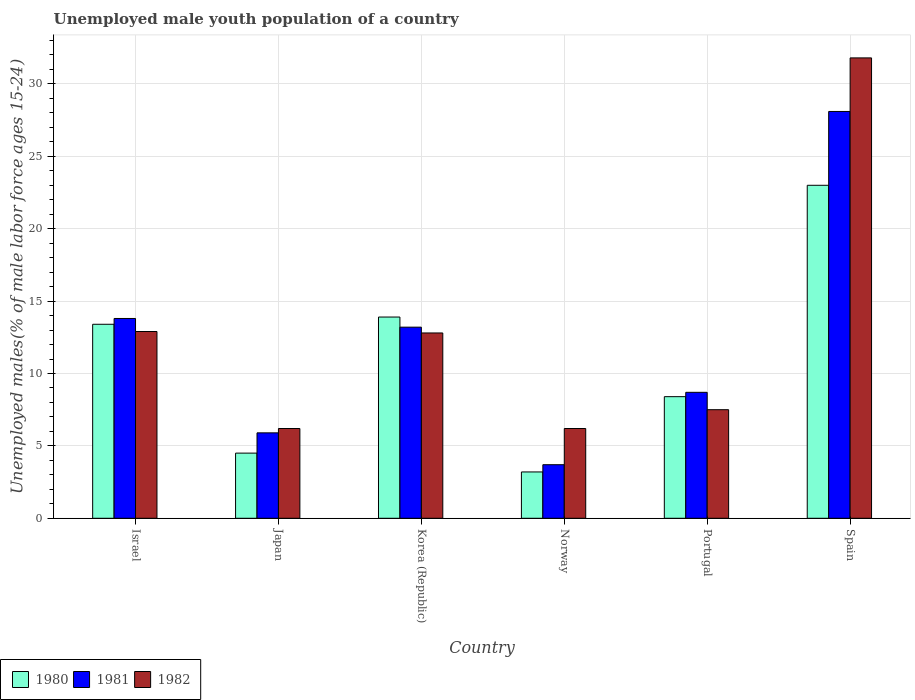How many groups of bars are there?
Provide a short and direct response. 6. How many bars are there on the 3rd tick from the right?
Keep it short and to the point. 3. What is the label of the 3rd group of bars from the left?
Your response must be concise. Korea (Republic). In how many cases, is the number of bars for a given country not equal to the number of legend labels?
Offer a very short reply. 0. What is the percentage of unemployed male youth population in 1980 in Norway?
Keep it short and to the point. 3.2. Across all countries, what is the maximum percentage of unemployed male youth population in 1980?
Your answer should be very brief. 23. Across all countries, what is the minimum percentage of unemployed male youth population in 1981?
Make the answer very short. 3.7. What is the total percentage of unemployed male youth population in 1981 in the graph?
Offer a terse response. 73.4. What is the difference between the percentage of unemployed male youth population in 1982 in Israel and that in Portugal?
Provide a short and direct response. 5.4. What is the difference between the percentage of unemployed male youth population in 1981 in Portugal and the percentage of unemployed male youth population in 1980 in Norway?
Your answer should be compact. 5.5. What is the average percentage of unemployed male youth population in 1982 per country?
Your answer should be compact. 12.9. What is the difference between the percentage of unemployed male youth population of/in 1981 and percentage of unemployed male youth population of/in 1982 in Portugal?
Keep it short and to the point. 1.2. In how many countries, is the percentage of unemployed male youth population in 1981 greater than 20 %?
Offer a terse response. 1. What is the ratio of the percentage of unemployed male youth population in 1981 in Japan to that in Norway?
Your response must be concise. 1.59. Is the difference between the percentage of unemployed male youth population in 1981 in Israel and Norway greater than the difference between the percentage of unemployed male youth population in 1982 in Israel and Norway?
Provide a short and direct response. Yes. What is the difference between the highest and the second highest percentage of unemployed male youth population in 1981?
Keep it short and to the point. -14.9. What is the difference between the highest and the lowest percentage of unemployed male youth population in 1981?
Make the answer very short. 24.4. What does the 3rd bar from the left in Portugal represents?
Your answer should be compact. 1982. Is it the case that in every country, the sum of the percentage of unemployed male youth population in 1980 and percentage of unemployed male youth population in 1981 is greater than the percentage of unemployed male youth population in 1982?
Keep it short and to the point. Yes. Are all the bars in the graph horizontal?
Ensure brevity in your answer.  No. How many countries are there in the graph?
Provide a succinct answer. 6. What is the difference between two consecutive major ticks on the Y-axis?
Your answer should be compact. 5. Are the values on the major ticks of Y-axis written in scientific E-notation?
Keep it short and to the point. No. Where does the legend appear in the graph?
Offer a very short reply. Bottom left. How many legend labels are there?
Your answer should be very brief. 3. How are the legend labels stacked?
Offer a terse response. Horizontal. What is the title of the graph?
Give a very brief answer. Unemployed male youth population of a country. Does "1963" appear as one of the legend labels in the graph?
Give a very brief answer. No. What is the label or title of the X-axis?
Give a very brief answer. Country. What is the label or title of the Y-axis?
Your answer should be very brief. Unemployed males(% of male labor force ages 15-24). What is the Unemployed males(% of male labor force ages 15-24) in 1980 in Israel?
Offer a very short reply. 13.4. What is the Unemployed males(% of male labor force ages 15-24) in 1981 in Israel?
Offer a terse response. 13.8. What is the Unemployed males(% of male labor force ages 15-24) in 1982 in Israel?
Give a very brief answer. 12.9. What is the Unemployed males(% of male labor force ages 15-24) in 1980 in Japan?
Provide a succinct answer. 4.5. What is the Unemployed males(% of male labor force ages 15-24) in 1981 in Japan?
Offer a very short reply. 5.9. What is the Unemployed males(% of male labor force ages 15-24) of 1982 in Japan?
Provide a short and direct response. 6.2. What is the Unemployed males(% of male labor force ages 15-24) in 1980 in Korea (Republic)?
Your answer should be compact. 13.9. What is the Unemployed males(% of male labor force ages 15-24) of 1981 in Korea (Republic)?
Offer a very short reply. 13.2. What is the Unemployed males(% of male labor force ages 15-24) in 1982 in Korea (Republic)?
Your answer should be compact. 12.8. What is the Unemployed males(% of male labor force ages 15-24) of 1980 in Norway?
Offer a terse response. 3.2. What is the Unemployed males(% of male labor force ages 15-24) in 1981 in Norway?
Provide a short and direct response. 3.7. What is the Unemployed males(% of male labor force ages 15-24) in 1982 in Norway?
Offer a terse response. 6.2. What is the Unemployed males(% of male labor force ages 15-24) in 1980 in Portugal?
Your response must be concise. 8.4. What is the Unemployed males(% of male labor force ages 15-24) in 1981 in Portugal?
Your answer should be very brief. 8.7. What is the Unemployed males(% of male labor force ages 15-24) of 1982 in Portugal?
Your response must be concise. 7.5. What is the Unemployed males(% of male labor force ages 15-24) in 1980 in Spain?
Make the answer very short. 23. What is the Unemployed males(% of male labor force ages 15-24) in 1981 in Spain?
Ensure brevity in your answer.  28.1. What is the Unemployed males(% of male labor force ages 15-24) in 1982 in Spain?
Offer a terse response. 31.8. Across all countries, what is the maximum Unemployed males(% of male labor force ages 15-24) in 1981?
Your answer should be very brief. 28.1. Across all countries, what is the maximum Unemployed males(% of male labor force ages 15-24) in 1982?
Provide a succinct answer. 31.8. Across all countries, what is the minimum Unemployed males(% of male labor force ages 15-24) in 1980?
Provide a succinct answer. 3.2. Across all countries, what is the minimum Unemployed males(% of male labor force ages 15-24) of 1981?
Provide a short and direct response. 3.7. Across all countries, what is the minimum Unemployed males(% of male labor force ages 15-24) in 1982?
Offer a very short reply. 6.2. What is the total Unemployed males(% of male labor force ages 15-24) in 1980 in the graph?
Your answer should be compact. 66.4. What is the total Unemployed males(% of male labor force ages 15-24) of 1981 in the graph?
Your answer should be very brief. 73.4. What is the total Unemployed males(% of male labor force ages 15-24) in 1982 in the graph?
Provide a short and direct response. 77.4. What is the difference between the Unemployed males(% of male labor force ages 15-24) of 1980 in Israel and that in Japan?
Offer a very short reply. 8.9. What is the difference between the Unemployed males(% of male labor force ages 15-24) in 1981 in Israel and that in Norway?
Make the answer very short. 10.1. What is the difference between the Unemployed males(% of male labor force ages 15-24) of 1982 in Israel and that in Norway?
Offer a very short reply. 6.7. What is the difference between the Unemployed males(% of male labor force ages 15-24) of 1982 in Israel and that in Portugal?
Offer a terse response. 5.4. What is the difference between the Unemployed males(% of male labor force ages 15-24) of 1981 in Israel and that in Spain?
Offer a very short reply. -14.3. What is the difference between the Unemployed males(% of male labor force ages 15-24) in 1982 in Israel and that in Spain?
Provide a succinct answer. -18.9. What is the difference between the Unemployed males(% of male labor force ages 15-24) in 1980 in Japan and that in Korea (Republic)?
Give a very brief answer. -9.4. What is the difference between the Unemployed males(% of male labor force ages 15-24) of 1982 in Japan and that in Korea (Republic)?
Your response must be concise. -6.6. What is the difference between the Unemployed males(% of male labor force ages 15-24) of 1981 in Japan and that in Norway?
Your answer should be very brief. 2.2. What is the difference between the Unemployed males(% of male labor force ages 15-24) of 1981 in Japan and that in Portugal?
Offer a terse response. -2.8. What is the difference between the Unemployed males(% of male labor force ages 15-24) of 1980 in Japan and that in Spain?
Give a very brief answer. -18.5. What is the difference between the Unemployed males(% of male labor force ages 15-24) of 1981 in Japan and that in Spain?
Ensure brevity in your answer.  -22.2. What is the difference between the Unemployed males(% of male labor force ages 15-24) of 1982 in Japan and that in Spain?
Give a very brief answer. -25.6. What is the difference between the Unemployed males(% of male labor force ages 15-24) of 1980 in Korea (Republic) and that in Norway?
Ensure brevity in your answer.  10.7. What is the difference between the Unemployed males(% of male labor force ages 15-24) in 1982 in Korea (Republic) and that in Portugal?
Provide a short and direct response. 5.3. What is the difference between the Unemployed males(% of male labor force ages 15-24) in 1981 in Korea (Republic) and that in Spain?
Make the answer very short. -14.9. What is the difference between the Unemployed males(% of male labor force ages 15-24) in 1982 in Korea (Republic) and that in Spain?
Your answer should be very brief. -19. What is the difference between the Unemployed males(% of male labor force ages 15-24) in 1981 in Norway and that in Portugal?
Make the answer very short. -5. What is the difference between the Unemployed males(% of male labor force ages 15-24) of 1982 in Norway and that in Portugal?
Provide a succinct answer. -1.3. What is the difference between the Unemployed males(% of male labor force ages 15-24) in 1980 in Norway and that in Spain?
Provide a short and direct response. -19.8. What is the difference between the Unemployed males(% of male labor force ages 15-24) in 1981 in Norway and that in Spain?
Give a very brief answer. -24.4. What is the difference between the Unemployed males(% of male labor force ages 15-24) in 1982 in Norway and that in Spain?
Your response must be concise. -25.6. What is the difference between the Unemployed males(% of male labor force ages 15-24) in 1980 in Portugal and that in Spain?
Provide a short and direct response. -14.6. What is the difference between the Unemployed males(% of male labor force ages 15-24) of 1981 in Portugal and that in Spain?
Keep it short and to the point. -19.4. What is the difference between the Unemployed males(% of male labor force ages 15-24) of 1982 in Portugal and that in Spain?
Keep it short and to the point. -24.3. What is the difference between the Unemployed males(% of male labor force ages 15-24) in 1980 in Israel and the Unemployed males(% of male labor force ages 15-24) in 1981 in Japan?
Give a very brief answer. 7.5. What is the difference between the Unemployed males(% of male labor force ages 15-24) in 1981 in Israel and the Unemployed males(% of male labor force ages 15-24) in 1982 in Japan?
Keep it short and to the point. 7.6. What is the difference between the Unemployed males(% of male labor force ages 15-24) of 1981 in Israel and the Unemployed males(% of male labor force ages 15-24) of 1982 in Korea (Republic)?
Offer a terse response. 1. What is the difference between the Unemployed males(% of male labor force ages 15-24) of 1981 in Israel and the Unemployed males(% of male labor force ages 15-24) of 1982 in Norway?
Your response must be concise. 7.6. What is the difference between the Unemployed males(% of male labor force ages 15-24) in 1981 in Israel and the Unemployed males(% of male labor force ages 15-24) in 1982 in Portugal?
Give a very brief answer. 6.3. What is the difference between the Unemployed males(% of male labor force ages 15-24) of 1980 in Israel and the Unemployed males(% of male labor force ages 15-24) of 1981 in Spain?
Offer a terse response. -14.7. What is the difference between the Unemployed males(% of male labor force ages 15-24) in 1980 in Israel and the Unemployed males(% of male labor force ages 15-24) in 1982 in Spain?
Your response must be concise. -18.4. What is the difference between the Unemployed males(% of male labor force ages 15-24) in 1981 in Israel and the Unemployed males(% of male labor force ages 15-24) in 1982 in Spain?
Offer a very short reply. -18. What is the difference between the Unemployed males(% of male labor force ages 15-24) in 1981 in Japan and the Unemployed males(% of male labor force ages 15-24) in 1982 in Korea (Republic)?
Offer a terse response. -6.9. What is the difference between the Unemployed males(% of male labor force ages 15-24) in 1981 in Japan and the Unemployed males(% of male labor force ages 15-24) in 1982 in Norway?
Offer a very short reply. -0.3. What is the difference between the Unemployed males(% of male labor force ages 15-24) of 1980 in Japan and the Unemployed males(% of male labor force ages 15-24) of 1981 in Spain?
Give a very brief answer. -23.6. What is the difference between the Unemployed males(% of male labor force ages 15-24) of 1980 in Japan and the Unemployed males(% of male labor force ages 15-24) of 1982 in Spain?
Provide a succinct answer. -27.3. What is the difference between the Unemployed males(% of male labor force ages 15-24) in 1981 in Japan and the Unemployed males(% of male labor force ages 15-24) in 1982 in Spain?
Make the answer very short. -25.9. What is the difference between the Unemployed males(% of male labor force ages 15-24) in 1980 in Korea (Republic) and the Unemployed males(% of male labor force ages 15-24) in 1981 in Norway?
Offer a very short reply. 10.2. What is the difference between the Unemployed males(% of male labor force ages 15-24) of 1981 in Korea (Republic) and the Unemployed males(% of male labor force ages 15-24) of 1982 in Norway?
Your response must be concise. 7. What is the difference between the Unemployed males(% of male labor force ages 15-24) in 1980 in Korea (Republic) and the Unemployed males(% of male labor force ages 15-24) in 1981 in Portugal?
Keep it short and to the point. 5.2. What is the difference between the Unemployed males(% of male labor force ages 15-24) in 1980 in Korea (Republic) and the Unemployed males(% of male labor force ages 15-24) in 1981 in Spain?
Make the answer very short. -14.2. What is the difference between the Unemployed males(% of male labor force ages 15-24) in 1980 in Korea (Republic) and the Unemployed males(% of male labor force ages 15-24) in 1982 in Spain?
Your answer should be compact. -17.9. What is the difference between the Unemployed males(% of male labor force ages 15-24) in 1981 in Korea (Republic) and the Unemployed males(% of male labor force ages 15-24) in 1982 in Spain?
Give a very brief answer. -18.6. What is the difference between the Unemployed males(% of male labor force ages 15-24) of 1980 in Norway and the Unemployed males(% of male labor force ages 15-24) of 1981 in Portugal?
Provide a succinct answer. -5.5. What is the difference between the Unemployed males(% of male labor force ages 15-24) in 1980 in Norway and the Unemployed males(% of male labor force ages 15-24) in 1982 in Portugal?
Make the answer very short. -4.3. What is the difference between the Unemployed males(% of male labor force ages 15-24) in 1980 in Norway and the Unemployed males(% of male labor force ages 15-24) in 1981 in Spain?
Your answer should be very brief. -24.9. What is the difference between the Unemployed males(% of male labor force ages 15-24) of 1980 in Norway and the Unemployed males(% of male labor force ages 15-24) of 1982 in Spain?
Make the answer very short. -28.6. What is the difference between the Unemployed males(% of male labor force ages 15-24) in 1981 in Norway and the Unemployed males(% of male labor force ages 15-24) in 1982 in Spain?
Provide a succinct answer. -28.1. What is the difference between the Unemployed males(% of male labor force ages 15-24) of 1980 in Portugal and the Unemployed males(% of male labor force ages 15-24) of 1981 in Spain?
Offer a very short reply. -19.7. What is the difference between the Unemployed males(% of male labor force ages 15-24) in 1980 in Portugal and the Unemployed males(% of male labor force ages 15-24) in 1982 in Spain?
Make the answer very short. -23.4. What is the difference between the Unemployed males(% of male labor force ages 15-24) in 1981 in Portugal and the Unemployed males(% of male labor force ages 15-24) in 1982 in Spain?
Your response must be concise. -23.1. What is the average Unemployed males(% of male labor force ages 15-24) of 1980 per country?
Provide a short and direct response. 11.07. What is the average Unemployed males(% of male labor force ages 15-24) in 1981 per country?
Offer a terse response. 12.23. What is the average Unemployed males(% of male labor force ages 15-24) of 1982 per country?
Offer a very short reply. 12.9. What is the difference between the Unemployed males(% of male labor force ages 15-24) in 1981 and Unemployed males(% of male labor force ages 15-24) in 1982 in Japan?
Ensure brevity in your answer.  -0.3. What is the difference between the Unemployed males(% of male labor force ages 15-24) of 1980 and Unemployed males(% of male labor force ages 15-24) of 1981 in Korea (Republic)?
Give a very brief answer. 0.7. What is the difference between the Unemployed males(% of male labor force ages 15-24) of 1980 and Unemployed males(% of male labor force ages 15-24) of 1982 in Korea (Republic)?
Ensure brevity in your answer.  1.1. What is the difference between the Unemployed males(% of male labor force ages 15-24) of 1980 and Unemployed males(% of male labor force ages 15-24) of 1981 in Norway?
Your answer should be very brief. -0.5. What is the difference between the Unemployed males(% of male labor force ages 15-24) in 1980 and Unemployed males(% of male labor force ages 15-24) in 1982 in Portugal?
Provide a short and direct response. 0.9. What is the difference between the Unemployed males(% of male labor force ages 15-24) of 1981 and Unemployed males(% of male labor force ages 15-24) of 1982 in Portugal?
Keep it short and to the point. 1.2. What is the difference between the Unemployed males(% of male labor force ages 15-24) in 1980 and Unemployed males(% of male labor force ages 15-24) in 1982 in Spain?
Give a very brief answer. -8.8. What is the ratio of the Unemployed males(% of male labor force ages 15-24) in 1980 in Israel to that in Japan?
Your answer should be very brief. 2.98. What is the ratio of the Unemployed males(% of male labor force ages 15-24) of 1981 in Israel to that in Japan?
Offer a terse response. 2.34. What is the ratio of the Unemployed males(% of male labor force ages 15-24) in 1982 in Israel to that in Japan?
Your response must be concise. 2.08. What is the ratio of the Unemployed males(% of male labor force ages 15-24) in 1980 in Israel to that in Korea (Republic)?
Keep it short and to the point. 0.96. What is the ratio of the Unemployed males(% of male labor force ages 15-24) of 1981 in Israel to that in Korea (Republic)?
Your answer should be very brief. 1.05. What is the ratio of the Unemployed males(% of male labor force ages 15-24) in 1982 in Israel to that in Korea (Republic)?
Offer a very short reply. 1.01. What is the ratio of the Unemployed males(% of male labor force ages 15-24) of 1980 in Israel to that in Norway?
Your answer should be compact. 4.19. What is the ratio of the Unemployed males(% of male labor force ages 15-24) in 1981 in Israel to that in Norway?
Provide a short and direct response. 3.73. What is the ratio of the Unemployed males(% of male labor force ages 15-24) in 1982 in Israel to that in Norway?
Keep it short and to the point. 2.08. What is the ratio of the Unemployed males(% of male labor force ages 15-24) of 1980 in Israel to that in Portugal?
Offer a very short reply. 1.6. What is the ratio of the Unemployed males(% of male labor force ages 15-24) in 1981 in Israel to that in Portugal?
Offer a terse response. 1.59. What is the ratio of the Unemployed males(% of male labor force ages 15-24) in 1982 in Israel to that in Portugal?
Your answer should be compact. 1.72. What is the ratio of the Unemployed males(% of male labor force ages 15-24) of 1980 in Israel to that in Spain?
Your answer should be compact. 0.58. What is the ratio of the Unemployed males(% of male labor force ages 15-24) in 1981 in Israel to that in Spain?
Your response must be concise. 0.49. What is the ratio of the Unemployed males(% of male labor force ages 15-24) in 1982 in Israel to that in Spain?
Your response must be concise. 0.41. What is the ratio of the Unemployed males(% of male labor force ages 15-24) of 1980 in Japan to that in Korea (Republic)?
Ensure brevity in your answer.  0.32. What is the ratio of the Unemployed males(% of male labor force ages 15-24) of 1981 in Japan to that in Korea (Republic)?
Offer a terse response. 0.45. What is the ratio of the Unemployed males(% of male labor force ages 15-24) in 1982 in Japan to that in Korea (Republic)?
Give a very brief answer. 0.48. What is the ratio of the Unemployed males(% of male labor force ages 15-24) in 1980 in Japan to that in Norway?
Provide a short and direct response. 1.41. What is the ratio of the Unemployed males(% of male labor force ages 15-24) in 1981 in Japan to that in Norway?
Your answer should be very brief. 1.59. What is the ratio of the Unemployed males(% of male labor force ages 15-24) of 1980 in Japan to that in Portugal?
Provide a short and direct response. 0.54. What is the ratio of the Unemployed males(% of male labor force ages 15-24) of 1981 in Japan to that in Portugal?
Give a very brief answer. 0.68. What is the ratio of the Unemployed males(% of male labor force ages 15-24) of 1982 in Japan to that in Portugal?
Make the answer very short. 0.83. What is the ratio of the Unemployed males(% of male labor force ages 15-24) in 1980 in Japan to that in Spain?
Give a very brief answer. 0.2. What is the ratio of the Unemployed males(% of male labor force ages 15-24) of 1981 in Japan to that in Spain?
Ensure brevity in your answer.  0.21. What is the ratio of the Unemployed males(% of male labor force ages 15-24) in 1982 in Japan to that in Spain?
Offer a terse response. 0.2. What is the ratio of the Unemployed males(% of male labor force ages 15-24) of 1980 in Korea (Republic) to that in Norway?
Give a very brief answer. 4.34. What is the ratio of the Unemployed males(% of male labor force ages 15-24) of 1981 in Korea (Republic) to that in Norway?
Provide a succinct answer. 3.57. What is the ratio of the Unemployed males(% of male labor force ages 15-24) in 1982 in Korea (Republic) to that in Norway?
Offer a terse response. 2.06. What is the ratio of the Unemployed males(% of male labor force ages 15-24) in 1980 in Korea (Republic) to that in Portugal?
Provide a succinct answer. 1.65. What is the ratio of the Unemployed males(% of male labor force ages 15-24) of 1981 in Korea (Republic) to that in Portugal?
Ensure brevity in your answer.  1.52. What is the ratio of the Unemployed males(% of male labor force ages 15-24) of 1982 in Korea (Republic) to that in Portugal?
Make the answer very short. 1.71. What is the ratio of the Unemployed males(% of male labor force ages 15-24) of 1980 in Korea (Republic) to that in Spain?
Give a very brief answer. 0.6. What is the ratio of the Unemployed males(% of male labor force ages 15-24) in 1981 in Korea (Republic) to that in Spain?
Your answer should be very brief. 0.47. What is the ratio of the Unemployed males(% of male labor force ages 15-24) in 1982 in Korea (Republic) to that in Spain?
Offer a terse response. 0.4. What is the ratio of the Unemployed males(% of male labor force ages 15-24) in 1980 in Norway to that in Portugal?
Keep it short and to the point. 0.38. What is the ratio of the Unemployed males(% of male labor force ages 15-24) in 1981 in Norway to that in Portugal?
Your answer should be compact. 0.43. What is the ratio of the Unemployed males(% of male labor force ages 15-24) of 1982 in Norway to that in Portugal?
Give a very brief answer. 0.83. What is the ratio of the Unemployed males(% of male labor force ages 15-24) in 1980 in Norway to that in Spain?
Your answer should be very brief. 0.14. What is the ratio of the Unemployed males(% of male labor force ages 15-24) in 1981 in Norway to that in Spain?
Give a very brief answer. 0.13. What is the ratio of the Unemployed males(% of male labor force ages 15-24) of 1982 in Norway to that in Spain?
Your answer should be very brief. 0.2. What is the ratio of the Unemployed males(% of male labor force ages 15-24) in 1980 in Portugal to that in Spain?
Keep it short and to the point. 0.37. What is the ratio of the Unemployed males(% of male labor force ages 15-24) in 1981 in Portugal to that in Spain?
Make the answer very short. 0.31. What is the ratio of the Unemployed males(% of male labor force ages 15-24) of 1982 in Portugal to that in Spain?
Offer a very short reply. 0.24. What is the difference between the highest and the second highest Unemployed males(% of male labor force ages 15-24) of 1981?
Ensure brevity in your answer.  14.3. What is the difference between the highest and the second highest Unemployed males(% of male labor force ages 15-24) in 1982?
Your response must be concise. 18.9. What is the difference between the highest and the lowest Unemployed males(% of male labor force ages 15-24) of 1980?
Your answer should be very brief. 19.8. What is the difference between the highest and the lowest Unemployed males(% of male labor force ages 15-24) in 1981?
Your response must be concise. 24.4. What is the difference between the highest and the lowest Unemployed males(% of male labor force ages 15-24) of 1982?
Keep it short and to the point. 25.6. 